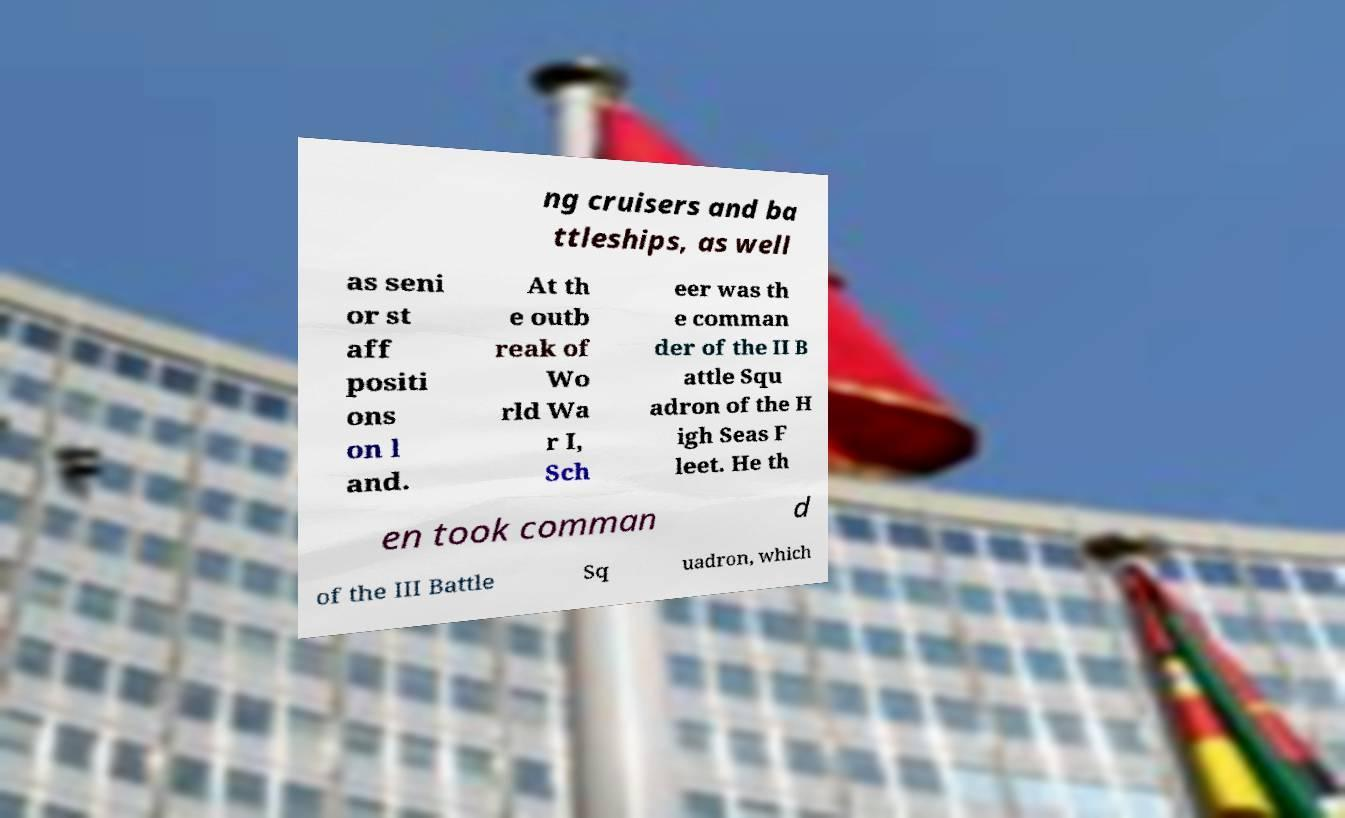Can you read and provide the text displayed in the image?This photo seems to have some interesting text. Can you extract and type it out for me? ng cruisers and ba ttleships, as well as seni or st aff positi ons on l and. At th e outb reak of Wo rld Wa r I, Sch eer was th e comman der of the II B attle Squ adron of the H igh Seas F leet. He th en took comman d of the III Battle Sq uadron, which 